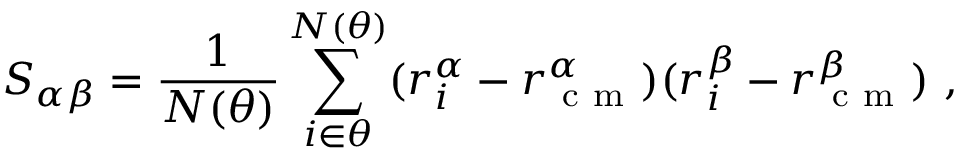Convert formula to latex. <formula><loc_0><loc_0><loc_500><loc_500>S _ { \alpha \beta } = { \frac { 1 } { N ( \theta ) } } \sum _ { i \in \theta } ^ { N ( \theta ) } ( r _ { i } ^ { \alpha } - r _ { c m } ^ { \alpha } ) ( r _ { i } ^ { \beta } - r _ { c m } ^ { \beta } ) ,</formula> 